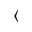Convert formula to latex. <formula><loc_0><loc_0><loc_500><loc_500>\langle</formula> 